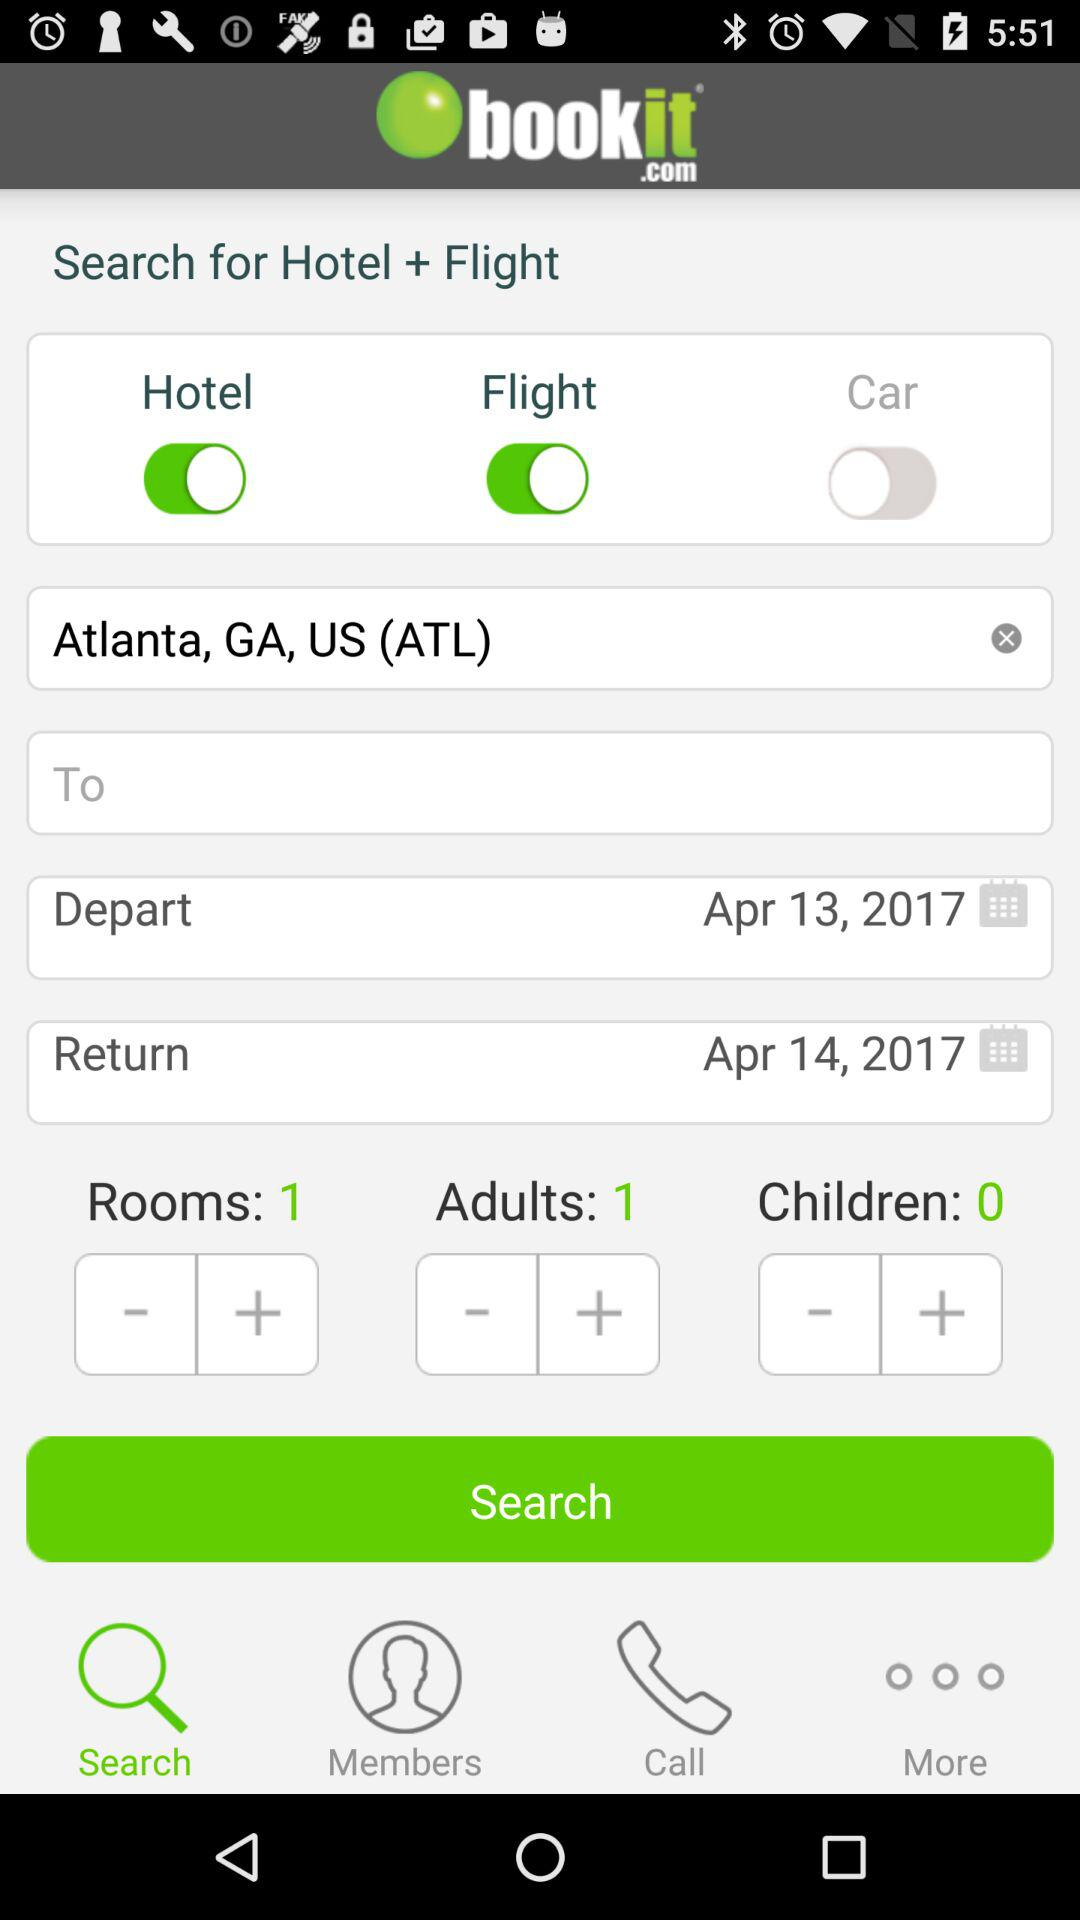What's the name of the departure point? The name of the departure point is Atlanta, GA, US (ATL). 